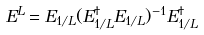<formula> <loc_0><loc_0><loc_500><loc_500>E ^ { L } = E _ { 1 / L } ( E _ { 1 / L } ^ { \dagger } E _ { 1 / L } ) ^ { - 1 } E _ { 1 / L } ^ { \dagger }</formula> 